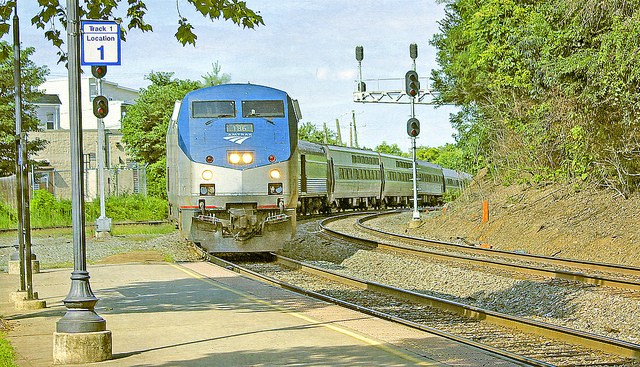Please transcribe the text information in this image. Track Location 1 1 